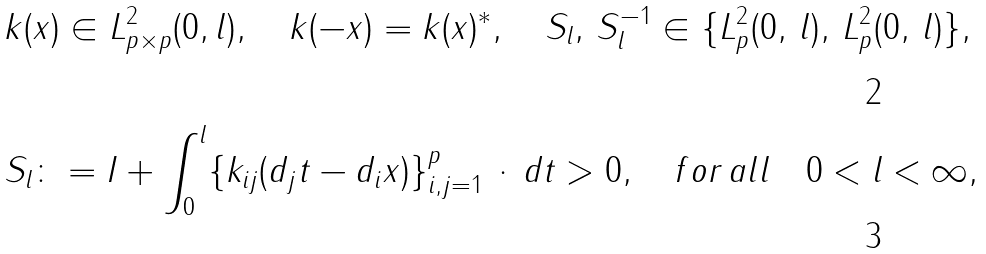<formula> <loc_0><loc_0><loc_500><loc_500>& k ( x ) \in L ^ { 2 } _ { p \times p } ( 0 , l ) , \quad k ( - x ) = k ( x ) ^ { * } , \quad S _ { l } , \, S _ { l } ^ { - 1 } \in \{ L ^ { 2 } _ { p } ( 0 , \, l ) , \, L ^ { 2 } _ { p } ( 0 , \, l ) \} , \\ & S _ { l } \colon = I + \int _ { 0 } ^ { l } \{ k _ { i j } ( d _ { j } t - d _ { i } x ) \} _ { i , j = 1 } ^ { p } \, \cdot \, d t > 0 , \quad f o r \, a l l \quad 0 < l < \infty ,</formula> 